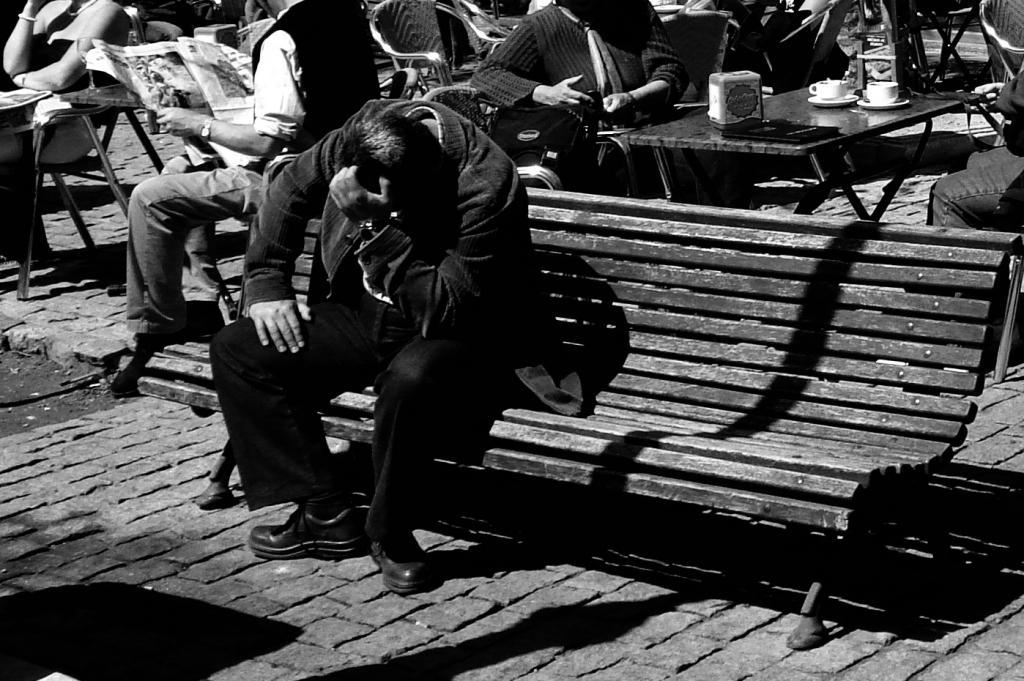Could you give a brief overview of what you see in this image? In this image we can see a person who is sitting on the bench and behind there are some other people sitting on the chairs around the tables on which there are some things. 